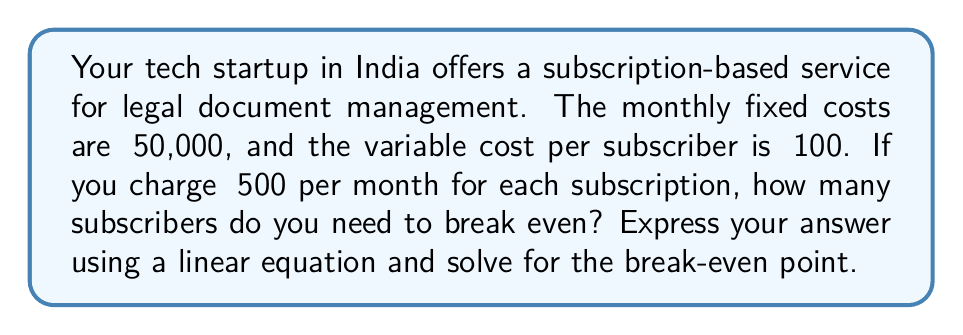Can you answer this question? Let's approach this step-by-step:

1) First, let's define our variables:
   $x$ = number of subscribers
   $R$ = total revenue
   $C$ = total cost

2) We can express revenue as a function of subscribers:
   $R = 500x$ (₹500 per subscriber)

3) We can express cost as a function of subscribers:
   $C = 50000 + 100x$ (₹50,000 fixed cost + ₹100 per subscriber)

4) At the break-even point, revenue equals cost:
   $R = C$

5) Substituting our equations:
   $500x = 50000 + 100x$

6) Solving for $x$:
   $500x - 100x = 50000$
   $400x = 50000$
   $x = \frac{50000}{400} = 125$

Therefore, the break-even point occurs at 125 subscribers.

To express this as a linear equation, we can rearrange step 5:
$500x - (50000 + 100x) = 0$
$400x - 50000 = 0$

This is in the form of $mx + b = 0$, where $m = 400$ and $b = -50000$.
Answer: 125 subscribers; $400x - 50000 = 0$ 